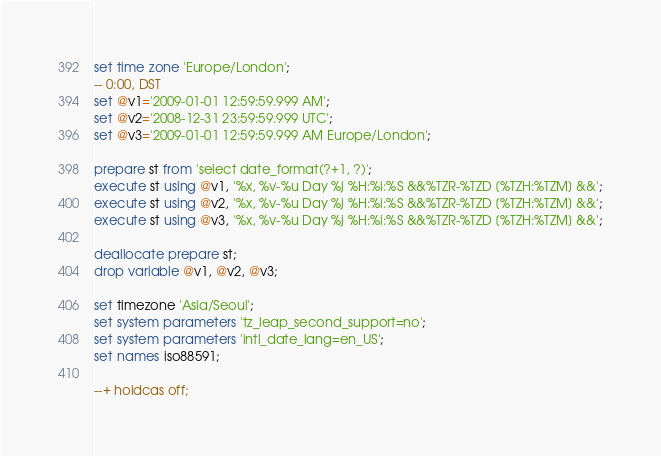Convert code to text. <code><loc_0><loc_0><loc_500><loc_500><_SQL_>set time zone 'Europe/London';
-- 0:00, DST
set @v1='2009-01-01 12:59:59.999 AM';
set @v2='2008-12-31 23:59:59.999 UTC';
set @v3='2009-01-01 12:59:59.999 AM Europe/London';

prepare st from 'select date_format(?+1, ?)';
execute st using @v1, '%x, %v-%u Day %j %H:%i:%S &&%TZR-%TZD [%TZH:%TZM] &&';
execute st using @v2, '%x, %v-%u Day %j %H:%i:%S &&%TZR-%TZD [%TZH:%TZM] &&';
execute st using @v3, '%x, %v-%u Day %j %H:%i:%S &&%TZR-%TZD [%TZH:%TZM] &&';

deallocate prepare st;
drop variable @v1, @v2, @v3;

set timezone 'Asia/Seoul';
set system parameters 'tz_leap_second_support=no';
set system parameters 'intl_date_lang=en_US';
set names iso88591;

--+ holdcas off;
</code> 